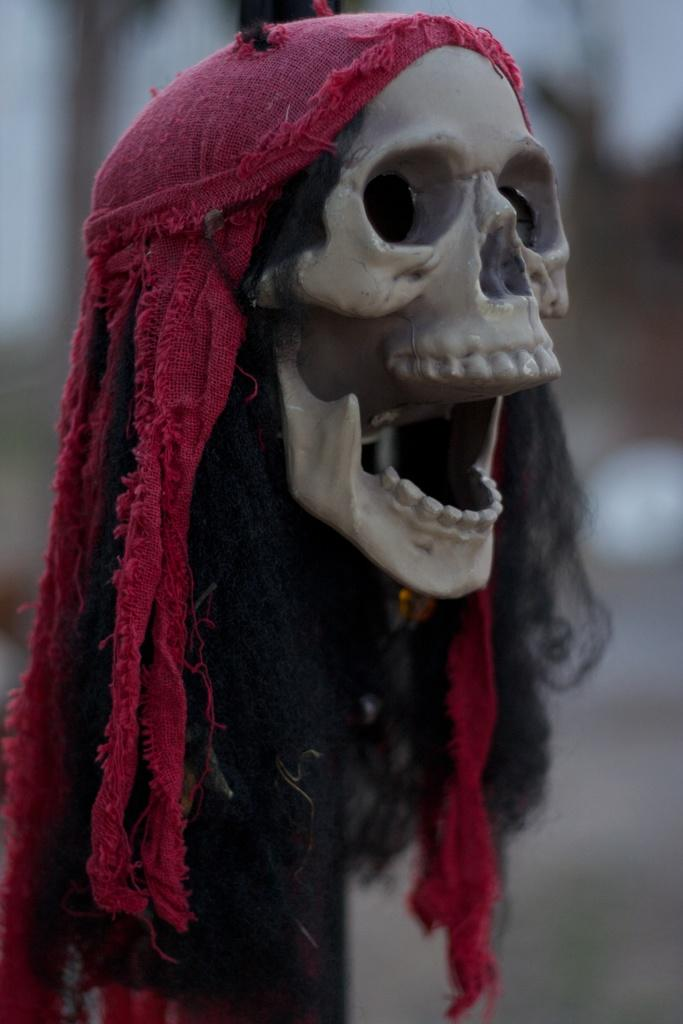What is the main subject of the image? The main subject of the image is a skull. Can you describe the skull's appearance? The skull has some hair on it and cloth covering parts of it. How would you describe the background of the image? The background of the image is blurry. Can you see any plants growing around the skull in the image? There are no plants visible in the image; it only features a skull with hair and cloth. 